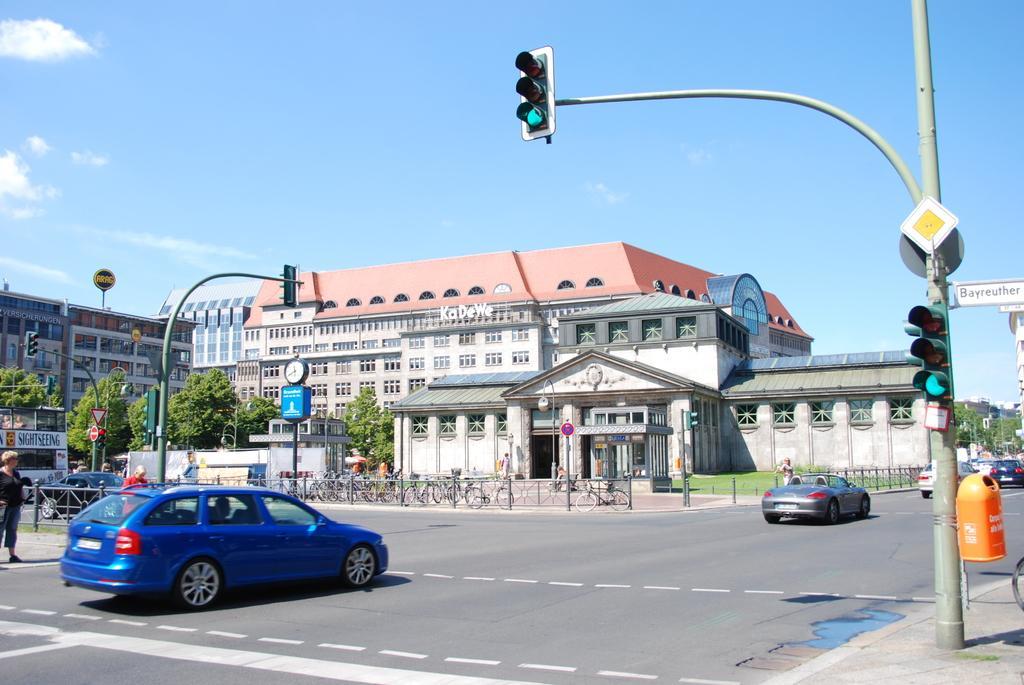In one or two sentences, can you explain what this image depicts? In the foreground of this image, there is a traffic signal pole on the pavement on the right. We can also see few vehicles moving on the road. In the background, there are few poles, trees, grass, railing, bicycles, few people standing, buildings and the sky. 